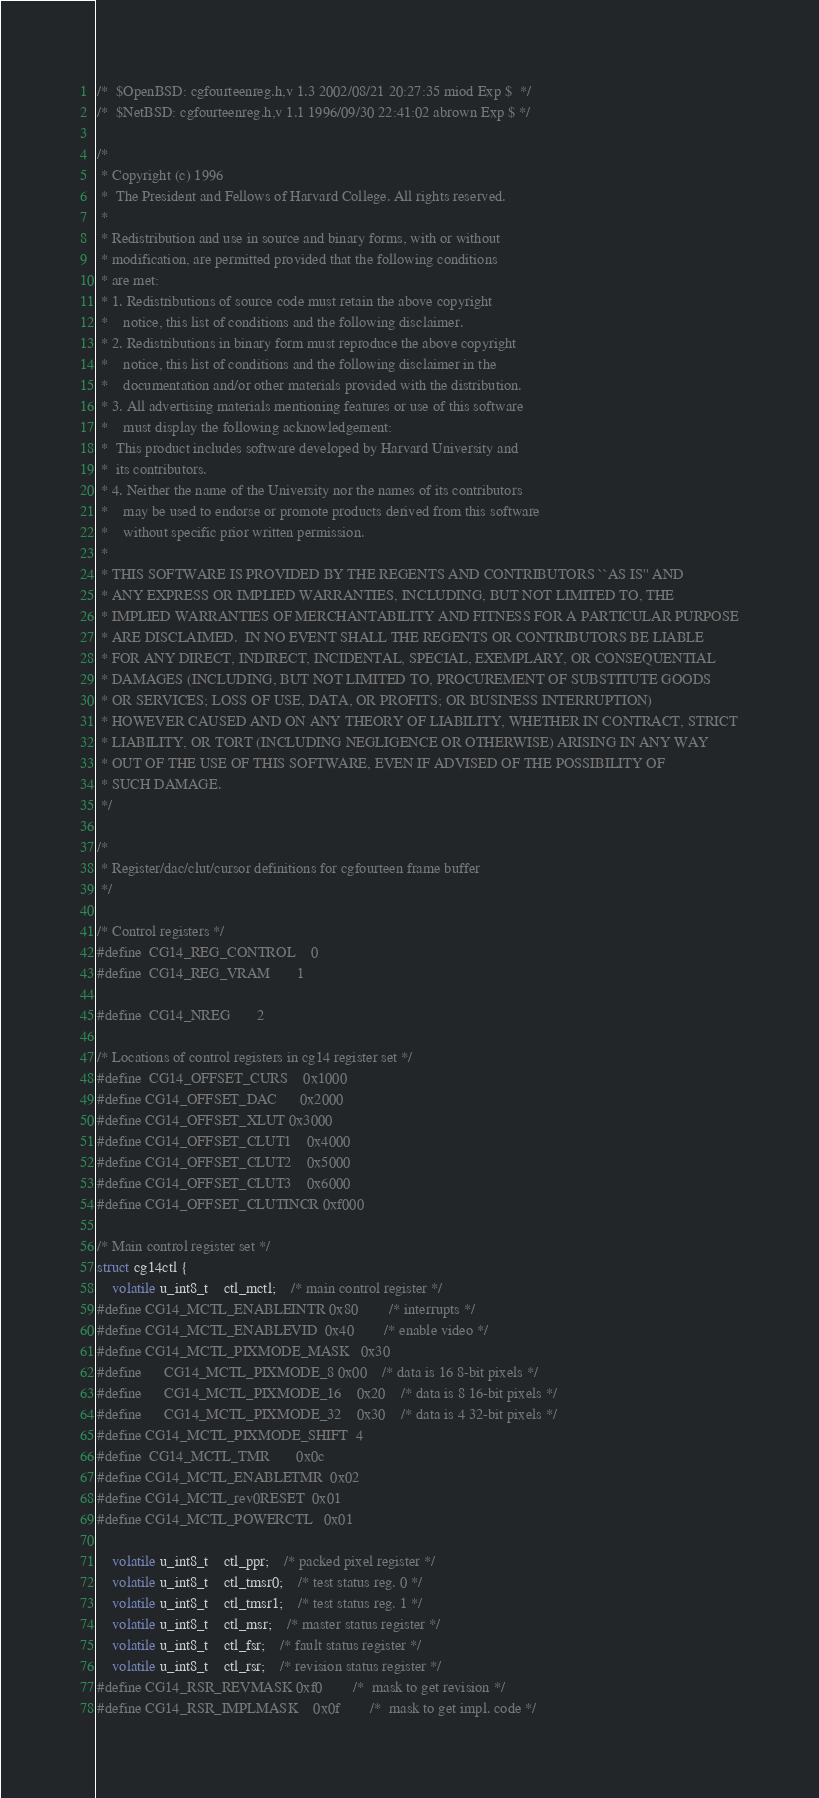<code> <loc_0><loc_0><loc_500><loc_500><_C_>/*	$OpenBSD: cgfourteenreg.h,v 1.3 2002/08/21 20:27:35 miod Exp $	*/
/*	$NetBSD: cgfourteenreg.h,v 1.1 1996/09/30 22:41:02 abrown Exp $ */

/*
 * Copyright (c) 1996
 *	The President and Fellows of Harvard College. All rights reserved.
 *
 * Redistribution and use in source and binary forms, with or without
 * modification, are permitted provided that the following conditions
 * are met:
 * 1. Redistributions of source code must retain the above copyright
 *    notice, this list of conditions and the following disclaimer.
 * 2. Redistributions in binary form must reproduce the above copyright
 *    notice, this list of conditions and the following disclaimer in the
 *    documentation and/or other materials provided with the distribution.
 * 3. All advertising materials mentioning features or use of this software
 *    must display the following acknowledgement:
 *	This product includes software developed by Harvard University and
 *	its contributors.
 * 4. Neither the name of the University nor the names of its contributors
 *    may be used to endorse or promote products derived from this software
 *    without specific prior written permission.
 *
 * THIS SOFTWARE IS PROVIDED BY THE REGENTS AND CONTRIBUTORS ``AS IS'' AND
 * ANY EXPRESS OR IMPLIED WARRANTIES, INCLUDING, BUT NOT LIMITED TO, THE
 * IMPLIED WARRANTIES OF MERCHANTABILITY AND FITNESS FOR A PARTICULAR PURPOSE
 * ARE DISCLAIMED.  IN NO EVENT SHALL THE REGENTS OR CONTRIBUTORS BE LIABLE
 * FOR ANY DIRECT, INDIRECT, INCIDENTAL, SPECIAL, EXEMPLARY, OR CONSEQUENTIAL
 * DAMAGES (INCLUDING, BUT NOT LIMITED TO, PROCUREMENT OF SUBSTITUTE GOODS
 * OR SERVICES; LOSS OF USE, DATA, OR PROFITS; OR BUSINESS INTERRUPTION)
 * HOWEVER CAUSED AND ON ANY THEORY OF LIABILITY, WHETHER IN CONTRACT, STRICT
 * LIABILITY, OR TORT (INCLUDING NEGLIGENCE OR OTHERWISE) ARISING IN ANY WAY
 * OUT OF THE USE OF THIS SOFTWARE, EVEN IF ADVISED OF THE POSSIBILITY OF
 * SUCH DAMAGE.
 */

/*
 * Register/dac/clut/cursor definitions for cgfourteen frame buffer
 */

/* Control registers */
#define	CG14_REG_CONTROL	0
#define	CG14_REG_VRAM		1

#define	CG14_NREG		2

/* Locations of control registers in cg14 register set */
#define	CG14_OFFSET_CURS	0x1000
#define CG14_OFFSET_DAC		0x2000
#define CG14_OFFSET_XLUT	0x3000
#define CG14_OFFSET_CLUT1	0x4000
#define CG14_OFFSET_CLUT2	0x5000
#define CG14_OFFSET_CLUT3	0x6000
#define CG14_OFFSET_CLUTINCR	0xf000

/* Main control register set */
struct cg14ctl {
	volatile u_int8_t	ctl_mctl;	/* main control register */
#define CG14_MCTL_ENABLEINTR	0x80		/* interrupts */
#define CG14_MCTL_ENABLEVID	0x40		/* enable video */
#define CG14_MCTL_PIXMODE_MASK	0x30
#define		CG14_MCTL_PIXMODE_8	0x00	/* data is 16 8-bit pixels */
#define		CG14_MCTL_PIXMODE_16	0x20	/* data is 8 16-bit pixels */
#define		CG14_MCTL_PIXMODE_32	0x30	/* data is 4 32-bit pixels */
#define CG14_MCTL_PIXMODE_SHIFT	4
#define	CG14_MCTL_TMR		0x0c
#define CG14_MCTL_ENABLETMR	0x02
#define CG14_MCTL_rev0RESET	0x01
#define CG14_MCTL_POWERCTL	0x01

	volatile u_int8_t	ctl_ppr;	/* packed pixel register */
	volatile u_int8_t	ctl_tmsr0; 	/* test status reg. 0 */
	volatile u_int8_t	ctl_tmsr1;	/* test status reg. 1 */
	volatile u_int8_t	ctl_msr;	/* master status register */
	volatile u_int8_t	ctl_fsr;	/* fault status register */
	volatile u_int8_t	ctl_rsr;	/* revision status register */
#define CG14_RSR_REVMASK	0xf0 		/*  mask to get revision */
#define CG14_RSR_IMPLMASK	0x0f		/*  mask to get impl. code */</code> 